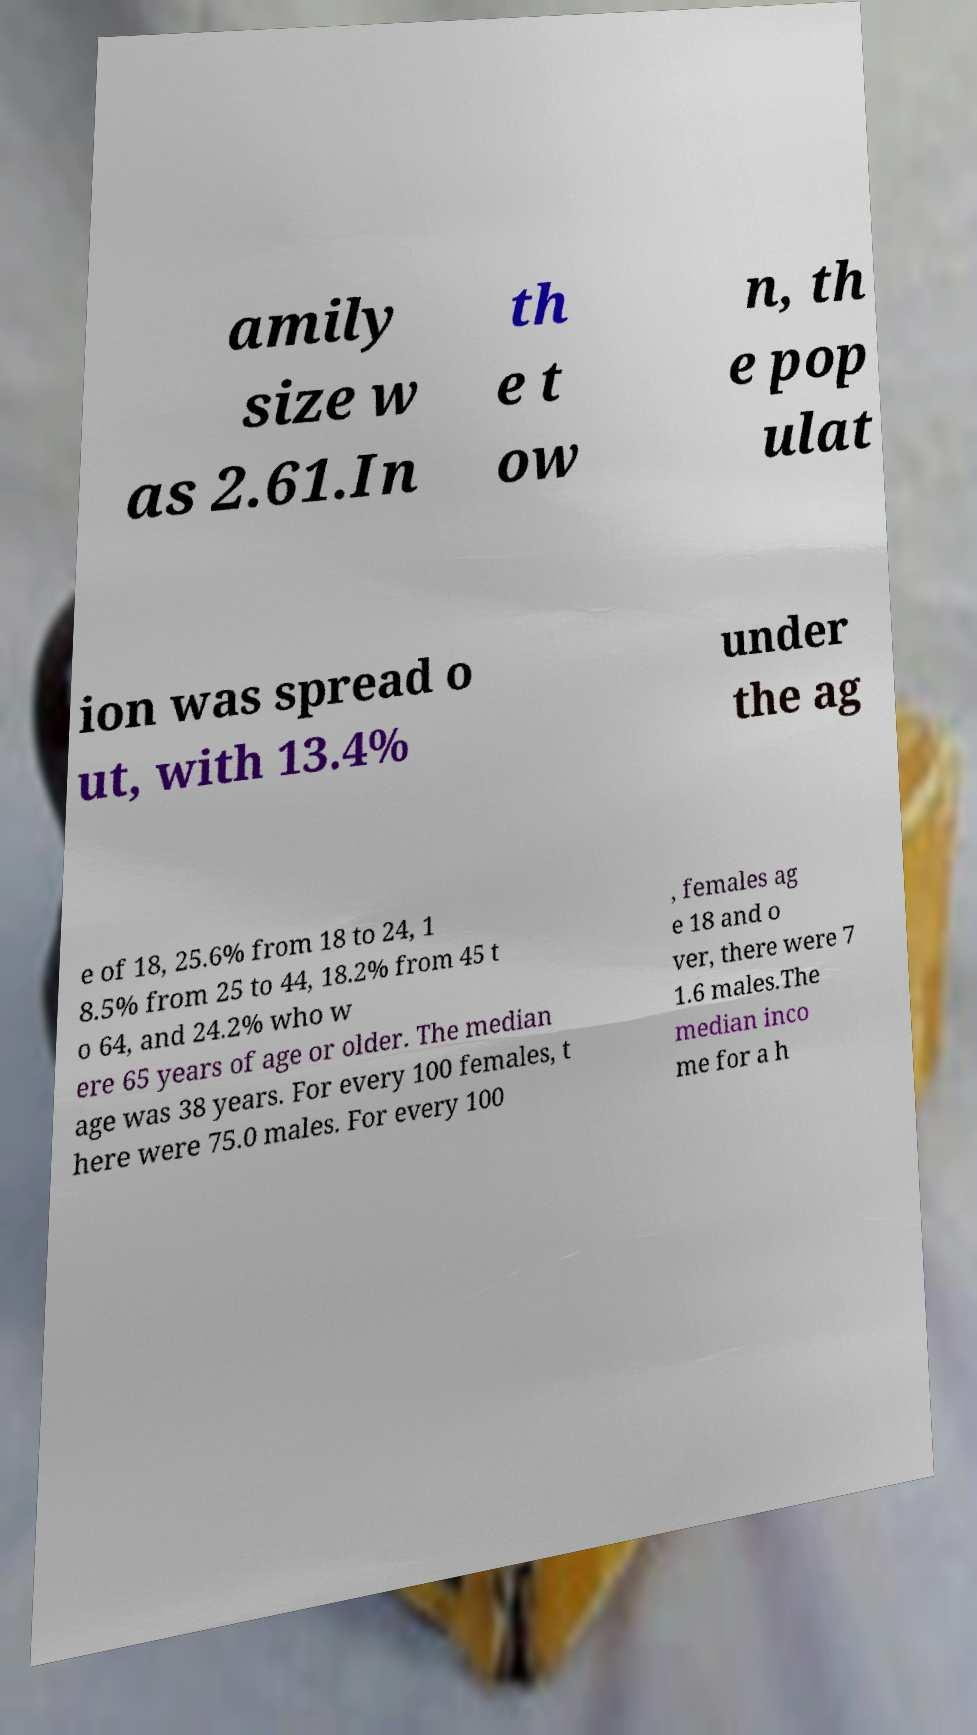Please identify and transcribe the text found in this image. amily size w as 2.61.In th e t ow n, th e pop ulat ion was spread o ut, with 13.4% under the ag e of 18, 25.6% from 18 to 24, 1 8.5% from 25 to 44, 18.2% from 45 t o 64, and 24.2% who w ere 65 years of age or older. The median age was 38 years. For every 100 females, t here were 75.0 males. For every 100 , females ag e 18 and o ver, there were 7 1.6 males.The median inco me for a h 